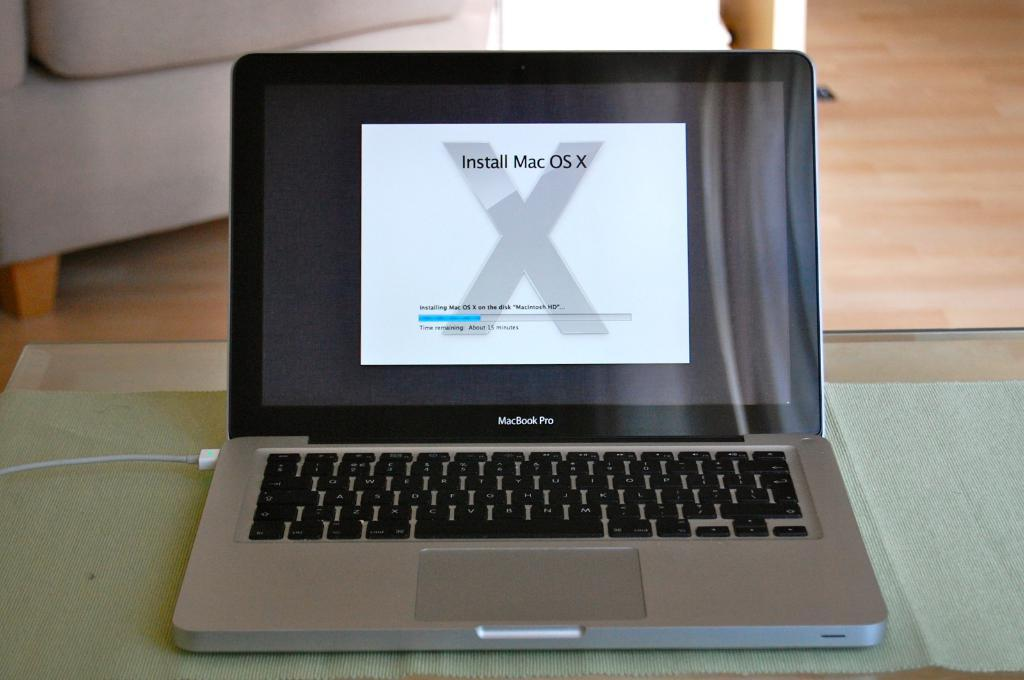<image>
Render a clear and concise summary of the photo. A laptop with the screen open and a warning to install Mac operating system. 